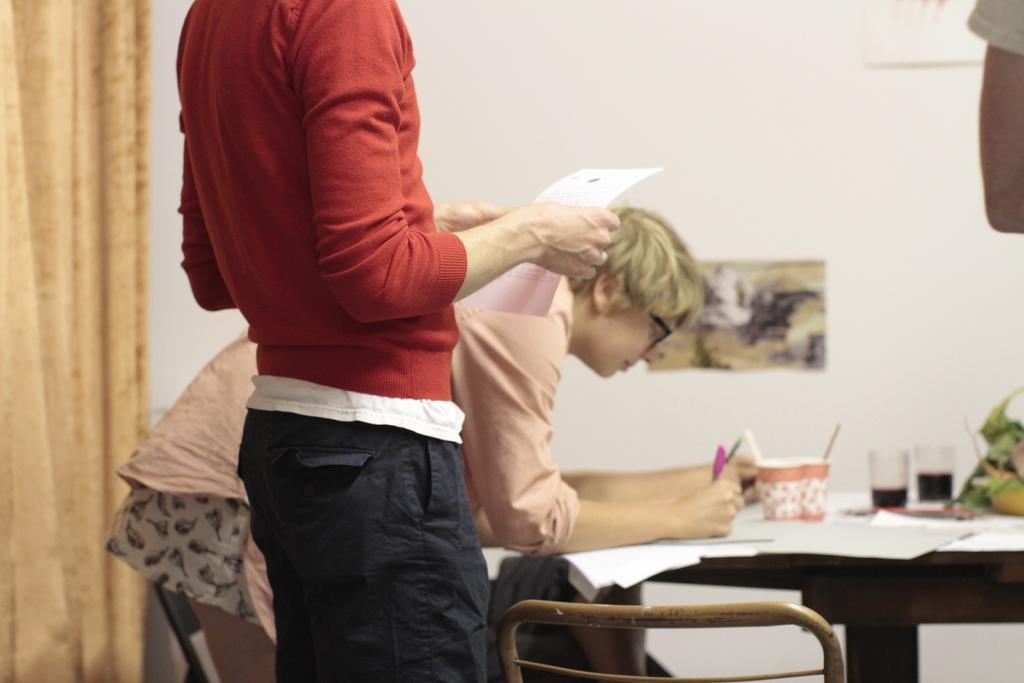Can you describe this image briefly? In this picture there is a boy who is standing on the left side of the image and there is a lady in the center of the image, she is writing, there is a table in front of her, on which there are glasses, there is a curtain on the left side of the image. 